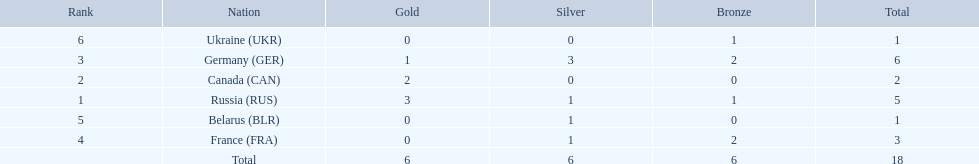Which countries had one or more gold medals? Russia (RUS), Canada (CAN), Germany (GER). Of these countries, which had at least one silver medal? Russia (RUS), Germany (GER). Of the remaining countries, who had more medals overall? Germany (GER). 